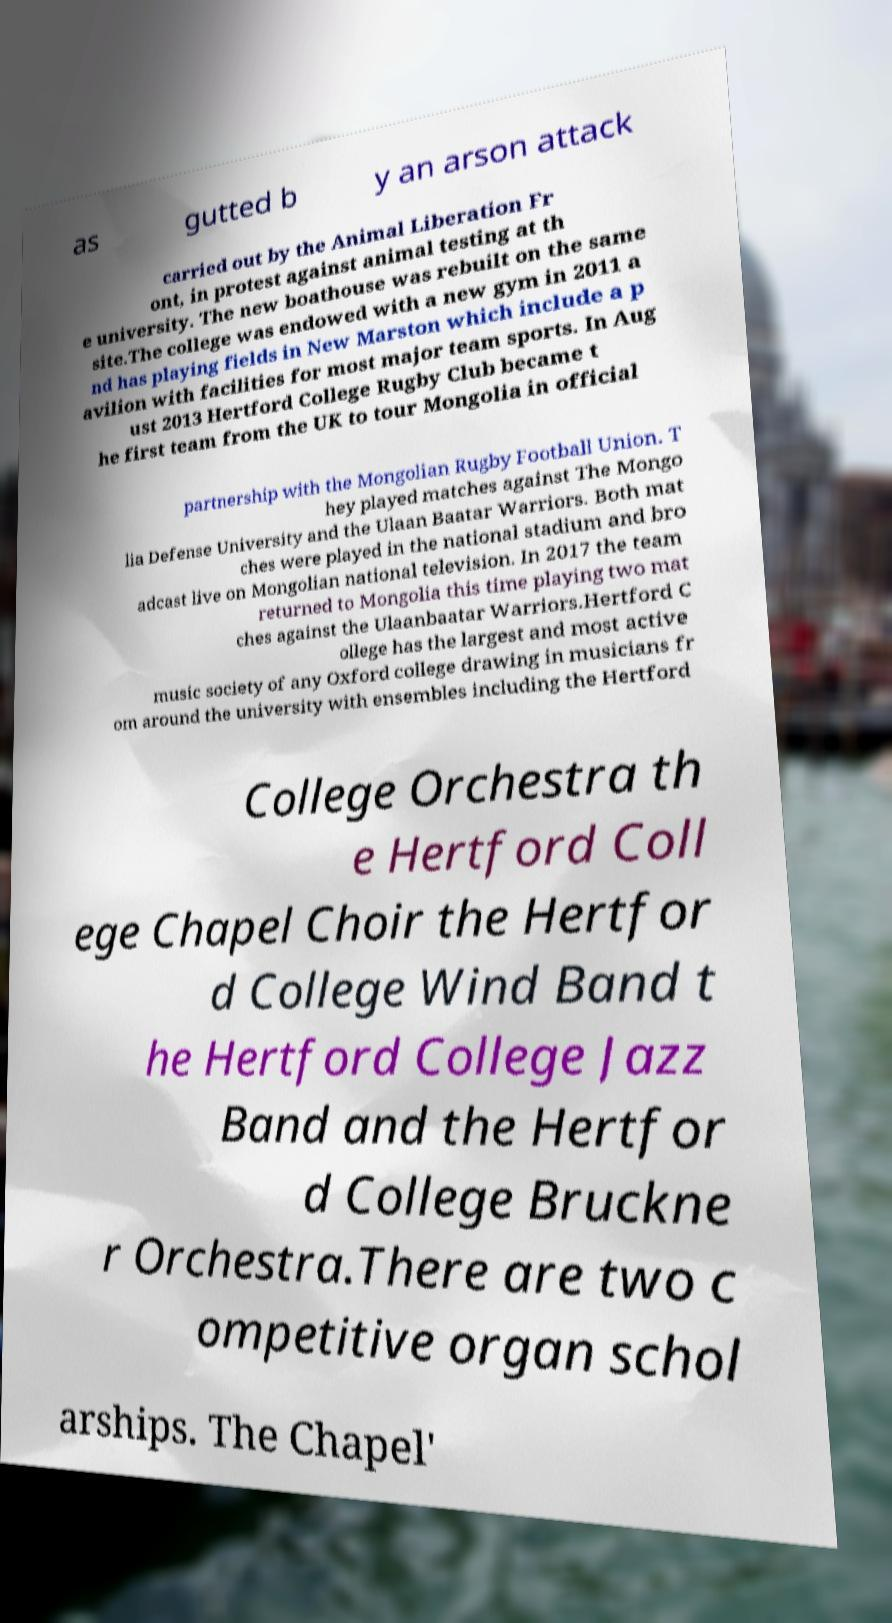Please identify and transcribe the text found in this image. as gutted b y an arson attack carried out by the Animal Liberation Fr ont, in protest against animal testing at th e university. The new boathouse was rebuilt on the same site.The college was endowed with a new gym in 2011 a nd has playing fields in New Marston which include a p avilion with facilities for most major team sports. In Aug ust 2013 Hertford College Rugby Club became t he first team from the UK to tour Mongolia in official partnership with the Mongolian Rugby Football Union. T hey played matches against The Mongo lia Defense University and the Ulaan Baatar Warriors. Both mat ches were played in the national stadium and bro adcast live on Mongolian national television. In 2017 the team returned to Mongolia this time playing two mat ches against the Ulaanbaatar Warriors.Hertford C ollege has the largest and most active music society of any Oxford college drawing in musicians fr om around the university with ensembles including the Hertford College Orchestra th e Hertford Coll ege Chapel Choir the Hertfor d College Wind Band t he Hertford College Jazz Band and the Hertfor d College Bruckne r Orchestra.There are two c ompetitive organ schol arships. The Chapel' 